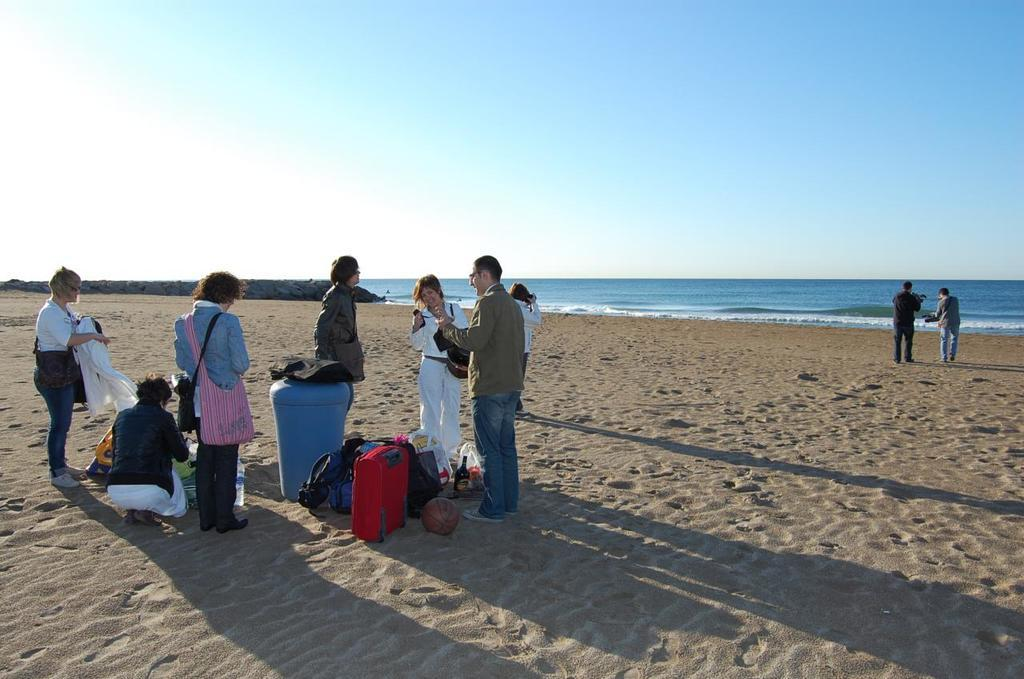What is the location of the people in the image? The people are standing on the beach sand. What objects are near the people? The people have luggage beside them. What can be seen in the background of the image? There is a sea in front of the people. What type of support can be seen in the image? There is no support visible in the image; it features people standing on the beach sand with luggage beside them and a sea in the background. How many hands are visible in the image? The number of hands cannot be determined from the image, as it only shows people standing on the beach sand with luggage beside them and a sea in the background. 